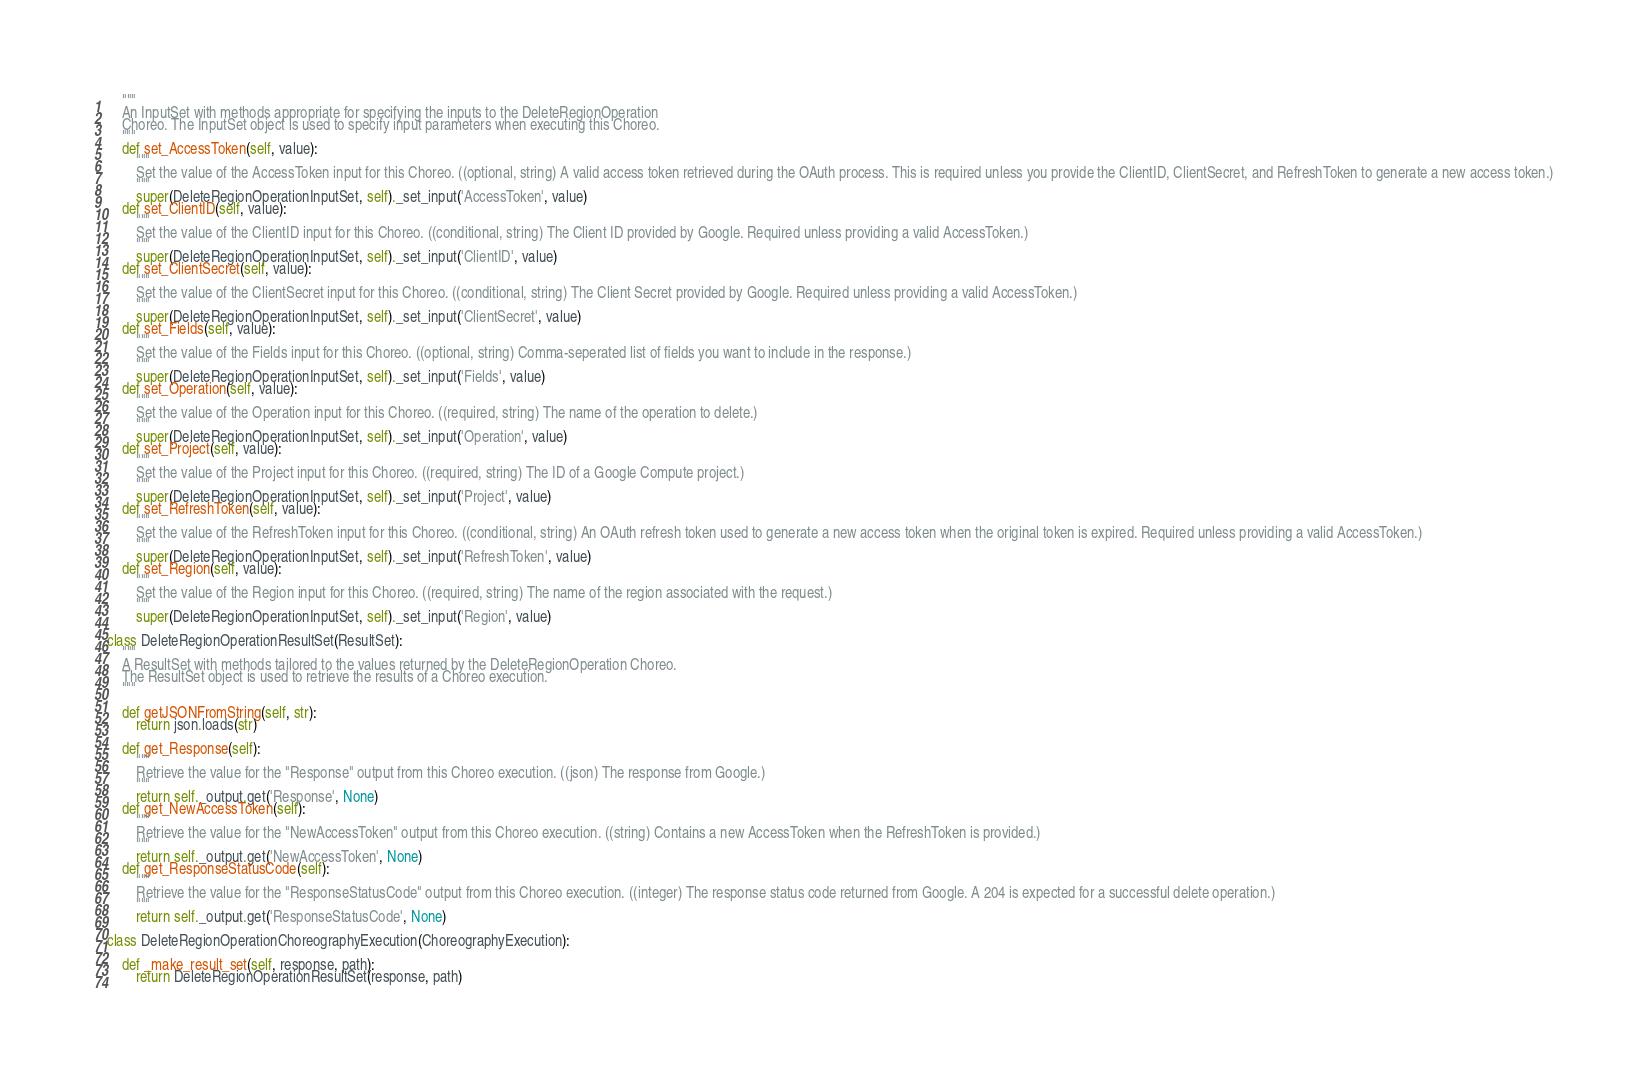Convert code to text. <code><loc_0><loc_0><loc_500><loc_500><_Python_>    """
    An InputSet with methods appropriate for specifying the inputs to the DeleteRegionOperation
    Choreo. The InputSet object is used to specify input parameters when executing this Choreo.
    """
    def set_AccessToken(self, value):
        """
        Set the value of the AccessToken input for this Choreo. ((optional, string) A valid access token retrieved during the OAuth process. This is required unless you provide the ClientID, ClientSecret, and RefreshToken to generate a new access token.)
        """
        super(DeleteRegionOperationInputSet, self)._set_input('AccessToken', value)
    def set_ClientID(self, value):
        """
        Set the value of the ClientID input for this Choreo. ((conditional, string) The Client ID provided by Google. Required unless providing a valid AccessToken.)
        """
        super(DeleteRegionOperationInputSet, self)._set_input('ClientID', value)
    def set_ClientSecret(self, value):
        """
        Set the value of the ClientSecret input for this Choreo. ((conditional, string) The Client Secret provided by Google. Required unless providing a valid AccessToken.)
        """
        super(DeleteRegionOperationInputSet, self)._set_input('ClientSecret', value)
    def set_Fields(self, value):
        """
        Set the value of the Fields input for this Choreo. ((optional, string) Comma-seperated list of fields you want to include in the response.)
        """
        super(DeleteRegionOperationInputSet, self)._set_input('Fields', value)
    def set_Operation(self, value):
        """
        Set the value of the Operation input for this Choreo. ((required, string) The name of the operation to delete.)
        """
        super(DeleteRegionOperationInputSet, self)._set_input('Operation', value)
    def set_Project(self, value):
        """
        Set the value of the Project input for this Choreo. ((required, string) The ID of a Google Compute project.)
        """
        super(DeleteRegionOperationInputSet, self)._set_input('Project', value)
    def set_RefreshToken(self, value):
        """
        Set the value of the RefreshToken input for this Choreo. ((conditional, string) An OAuth refresh token used to generate a new access token when the original token is expired. Required unless providing a valid AccessToken.)
        """
        super(DeleteRegionOperationInputSet, self)._set_input('RefreshToken', value)
    def set_Region(self, value):
        """
        Set the value of the Region input for this Choreo. ((required, string) The name of the region associated with the request.)
        """
        super(DeleteRegionOperationInputSet, self)._set_input('Region', value)

class DeleteRegionOperationResultSet(ResultSet):
    """
    A ResultSet with methods tailored to the values returned by the DeleteRegionOperation Choreo.
    The ResultSet object is used to retrieve the results of a Choreo execution.
    """

    def getJSONFromString(self, str):
        return json.loads(str)

    def get_Response(self):
        """
        Retrieve the value for the "Response" output from this Choreo execution. ((json) The response from Google.)
        """
        return self._output.get('Response', None)
    def get_NewAccessToken(self):
        """
        Retrieve the value for the "NewAccessToken" output from this Choreo execution. ((string) Contains a new AccessToken when the RefreshToken is provided.)
        """
        return self._output.get('NewAccessToken', None)
    def get_ResponseStatusCode(self):
        """
        Retrieve the value for the "ResponseStatusCode" output from this Choreo execution. ((integer) The response status code returned from Google. A 204 is expected for a successful delete operation.)
        """
        return self._output.get('ResponseStatusCode', None)

class DeleteRegionOperationChoreographyExecution(ChoreographyExecution):

    def _make_result_set(self, response, path):
        return DeleteRegionOperationResultSet(response, path)
</code> 